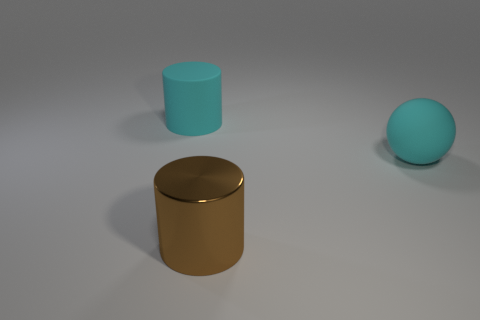How many large cyan rubber spheres are to the left of the cyan matte thing behind the cyan thing that is to the right of the brown cylinder?
Provide a succinct answer. 0. There is a object that is both on the left side of the large rubber ball and in front of the cyan rubber cylinder; what material is it made of?
Your answer should be compact. Metal. What color is the thing that is in front of the cyan cylinder and to the left of the large rubber ball?
Keep it short and to the point. Brown. Are there any other things of the same color as the matte cylinder?
Offer a terse response. Yes. There is a cyan thing that is to the left of the large cyan matte object to the right of the big cylinder that is behind the large ball; what is its shape?
Provide a short and direct response. Cylinder. There is another large thing that is the same shape as the brown object; what is its color?
Provide a succinct answer. Cyan. What color is the big cylinder that is on the right side of the cyan rubber thing that is left of the big cyan matte sphere?
Your response must be concise. Brown. What is the size of the cyan thing that is the same shape as the big brown metal thing?
Keep it short and to the point. Large. What number of big cyan objects have the same material as the cyan cylinder?
Keep it short and to the point. 1. There is a large thing that is on the left side of the large brown object; how many cyan cylinders are left of it?
Your answer should be very brief. 0. 